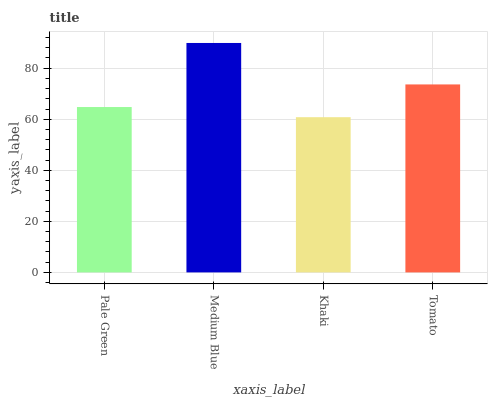Is Medium Blue the minimum?
Answer yes or no. No. Is Khaki the maximum?
Answer yes or no. No. Is Medium Blue greater than Khaki?
Answer yes or no. Yes. Is Khaki less than Medium Blue?
Answer yes or no. Yes. Is Khaki greater than Medium Blue?
Answer yes or no. No. Is Medium Blue less than Khaki?
Answer yes or no. No. Is Tomato the high median?
Answer yes or no. Yes. Is Pale Green the low median?
Answer yes or no. Yes. Is Khaki the high median?
Answer yes or no. No. Is Medium Blue the low median?
Answer yes or no. No. 